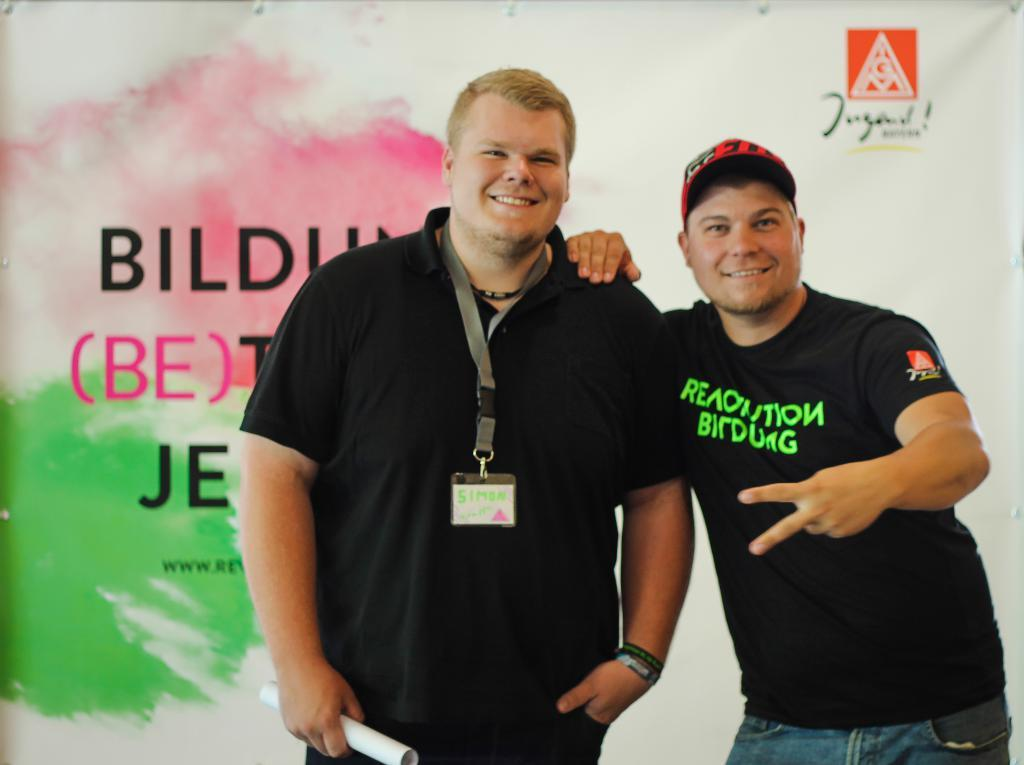How many people are in the image? There are two men in the image. What are the men doing in the image? The men are standing in the middle of the image and smiling. What color are the t-shirts worn by the men? The men are wearing black color t-shirts. What can be seen in the background of the image? There appears to be a banner in the background of the image. How many rabbits can be seen hopping around the men in the image? There are no rabbits present in the image; it features two men standing and smiling. What is the position of the moon in the image? There is no moon visible in the image. 